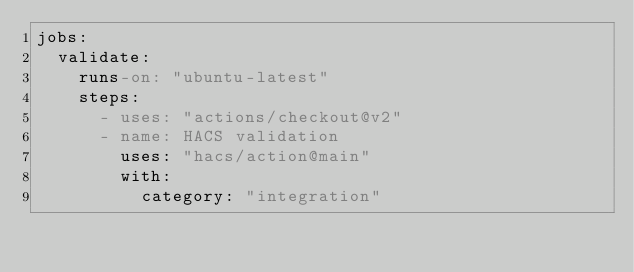<code> <loc_0><loc_0><loc_500><loc_500><_YAML_>jobs:
  validate:
    runs-on: "ubuntu-latest"
    steps:
      - uses: "actions/checkout@v2"
      - name: HACS validation
        uses: "hacs/action@main"
        with:
          category: "integration"</code> 